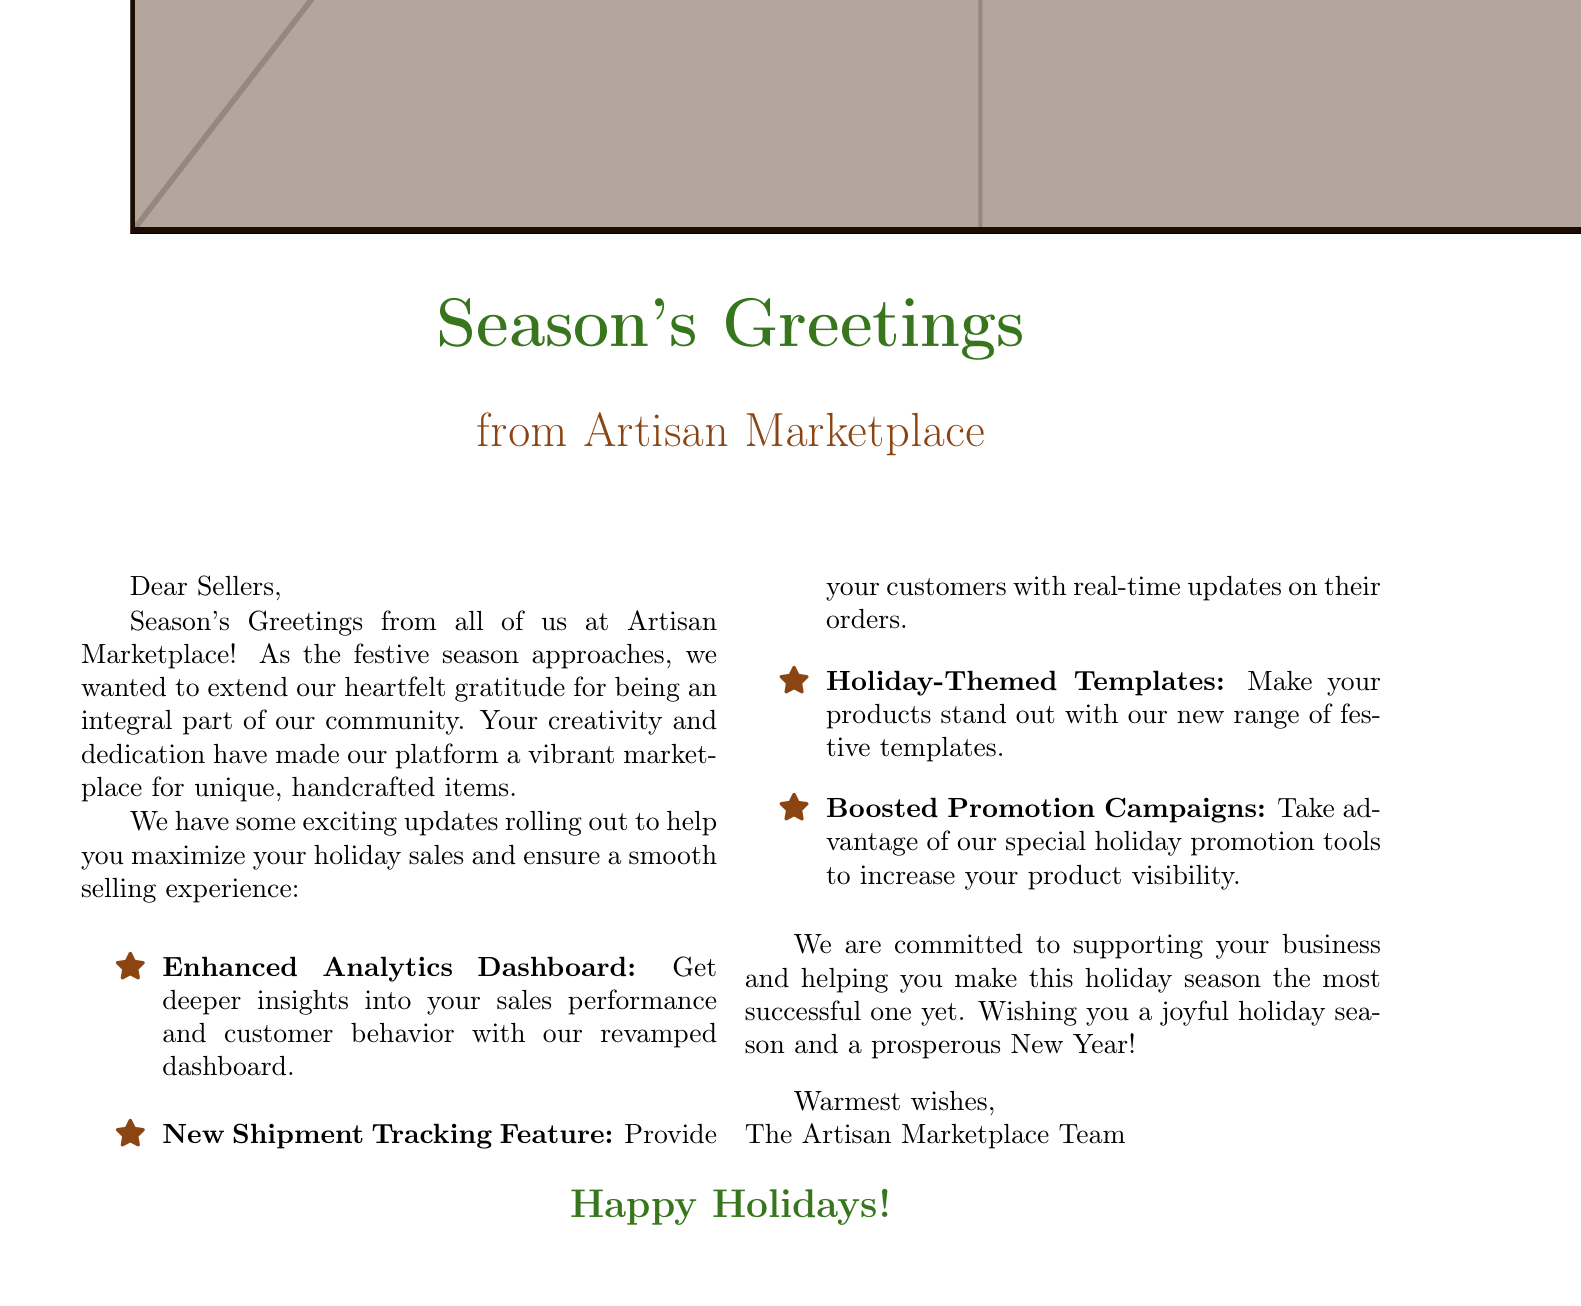What is the title of the greeting card? The title is typically prominently displayed at the top of the card; in this case, it is "Season's Greetings."
Answer: Season's Greetings What is the name of the platform sending the card? The name of the platform is indicated below the main title and states "from Artisan Marketplace."
Answer: Artisan Marketplace What is one of the upcoming updates mentioned in the card? The document lists several updates, and one example is "Enhanced Analytics Dashboard."
Answer: Enhanced Analytics Dashboard How many key updates are highlighted in the card? The document lists a total of four different updates for the sellers.
Answer: Four What sentiment does the card express towards the sellers? This card expresses gratitude and wishes the sellers a joyful holiday season, indicating warm feelings.
Answer: Gratitude What is the primary purpose of this greeting card? The main purpose is to convey holiday greetings while also informing sellers about important updates for holiday sales.
Answer: Holiday greetings What color is associated with the festive theme in the card? The color mentioned in the card that represents the festive theme is "rustic green."
Answer: Rustic green What is the closing message of the card? The closing message summarizes the card's sentiment and wishing the sellers well, concluding with warm regards from the team.
Answer: Warmest wishes 